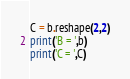<code> <loc_0><loc_0><loc_500><loc_500><_Python_>C = b.reshape(2,2)
print('B = ',b)
print('C = ',C)
</code> 